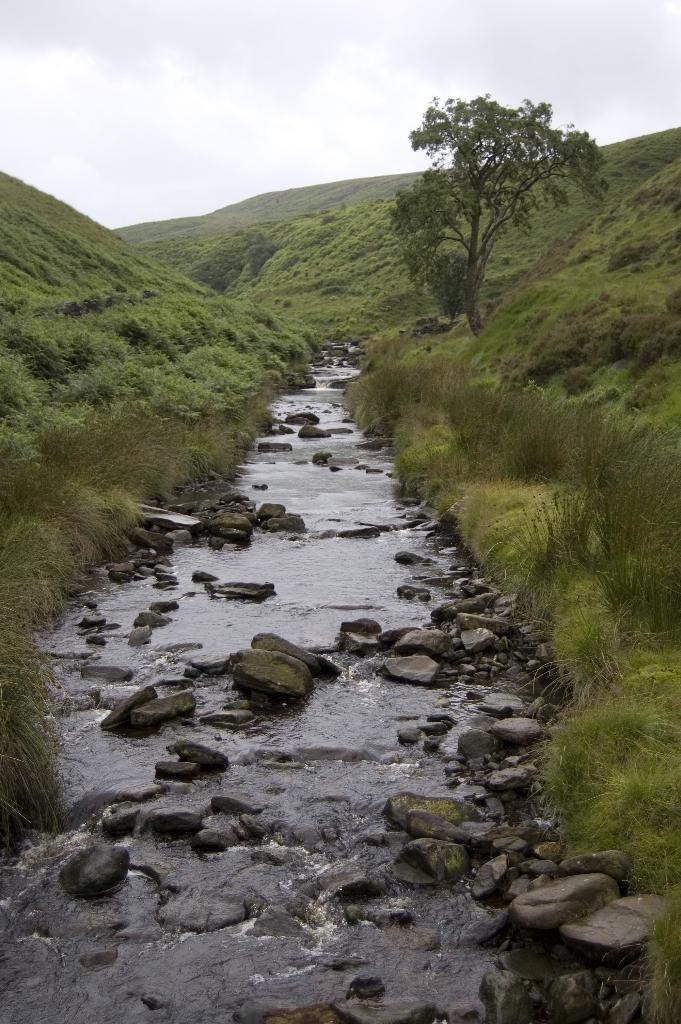What is the primary element visible in the image? There is water in the image. What other objects or features can be seen in the image? There are rocks, plants, and a tree in the image. What is visible in the background of the image? There are clouds visible in the background of the image. What type of glove is being played in the song that can be heard in the image? There is no glove or song present in the image; it features water, rocks, plants, a tree, and clouds. 